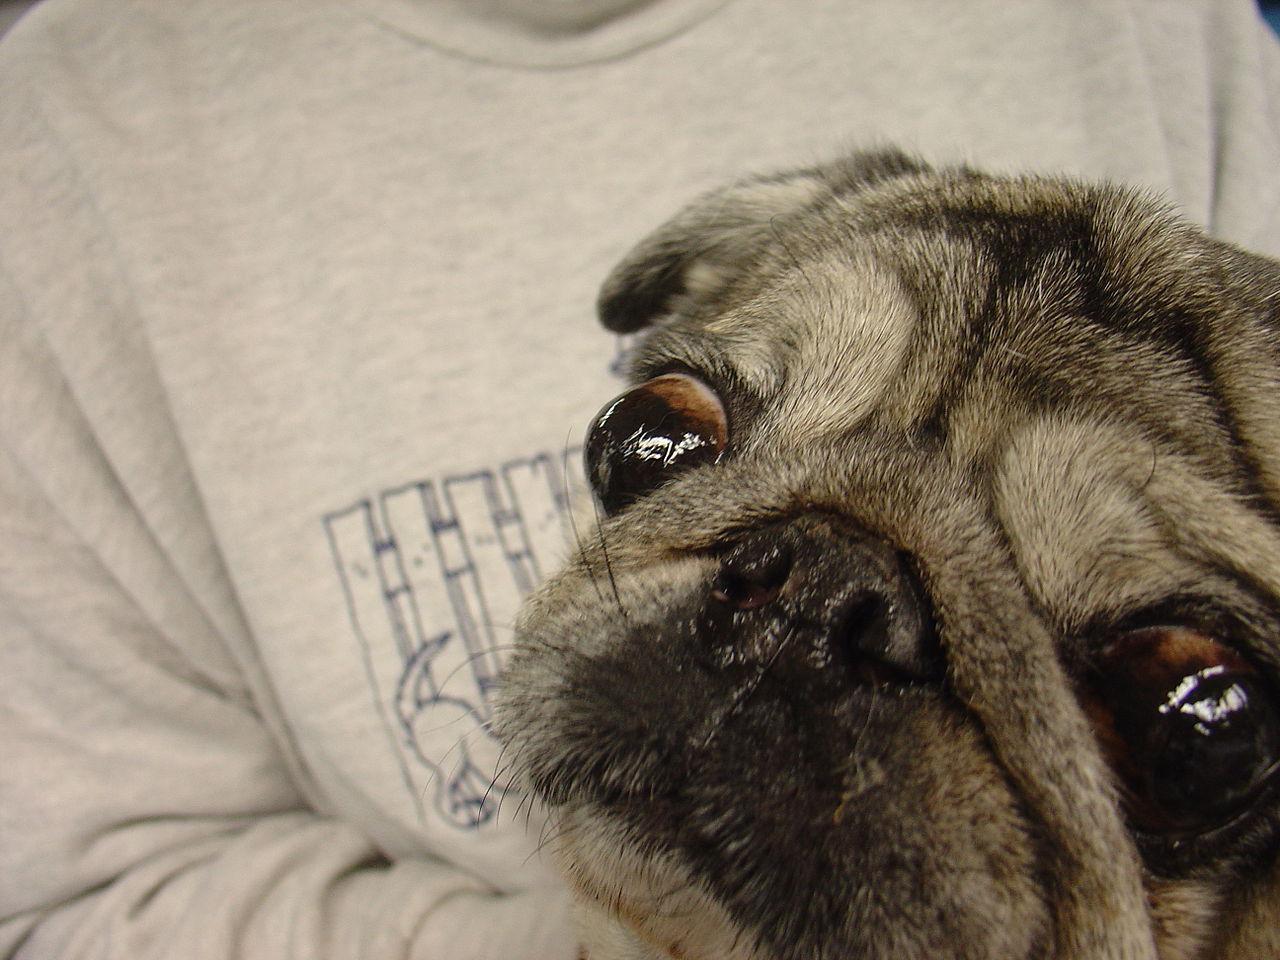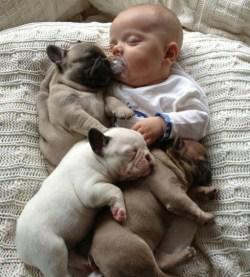The first image is the image on the left, the second image is the image on the right. For the images displayed, is the sentence "The right image contains no more than three dogs." factually correct? Answer yes or no. Yes. The first image is the image on the left, the second image is the image on the right. Considering the images on both sides, is "At least one of the dogs is near a human." valid? Answer yes or no. Yes. 